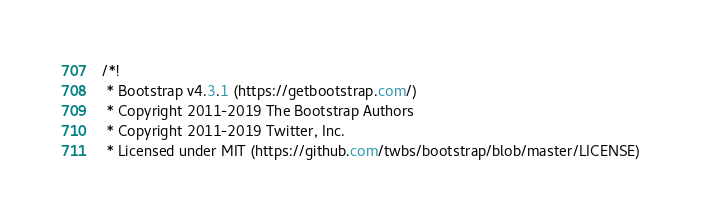<code> <loc_0><loc_0><loc_500><loc_500><_CSS_>/*!
 * Bootstrap v4.3.1 (https://getbootstrap.com/)
 * Copyright 2011-2019 The Bootstrap Authors
 * Copyright 2011-2019 Twitter, Inc.
 * Licensed under MIT (https://github.com/twbs/bootstrap/blob/master/LICENSE)</code> 